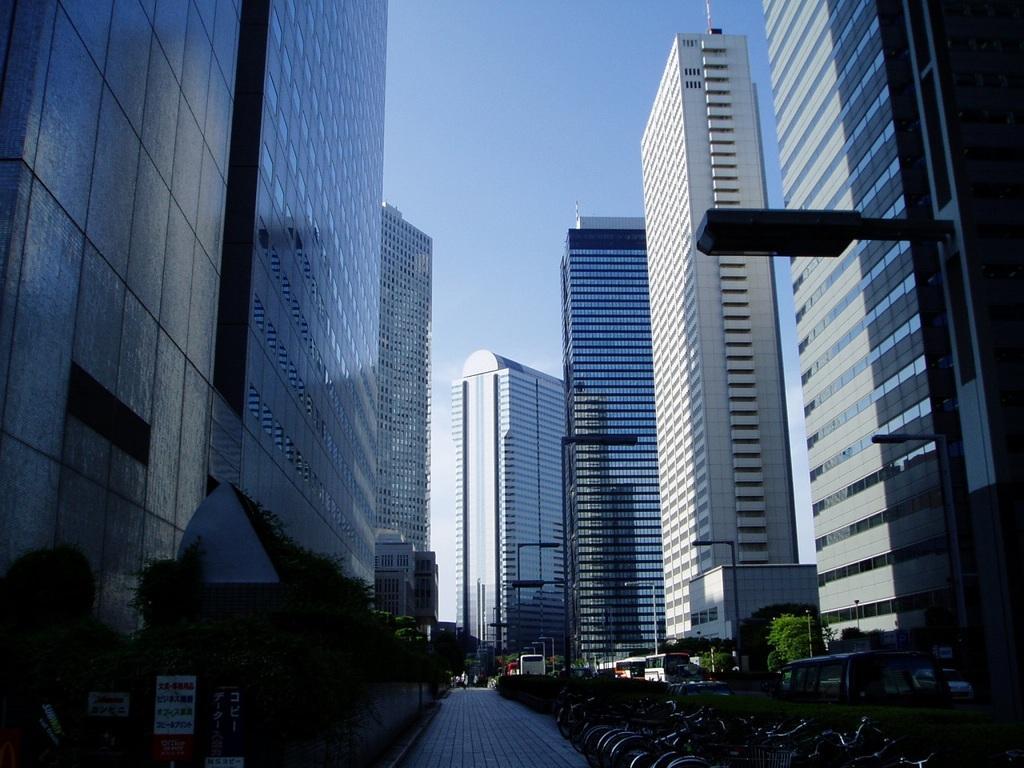In one or two sentences, can you explain what this image depicts? In this image, we can see buildings, trees, boards, poles, lights, some vehicles on the road and there are bicycles. At the top, there is sky. 